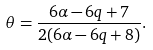<formula> <loc_0><loc_0><loc_500><loc_500>\theta = \frac { 6 \alpha - 6 q + 7 } { 2 ( 6 \alpha - 6 q + 8 ) } .</formula> 